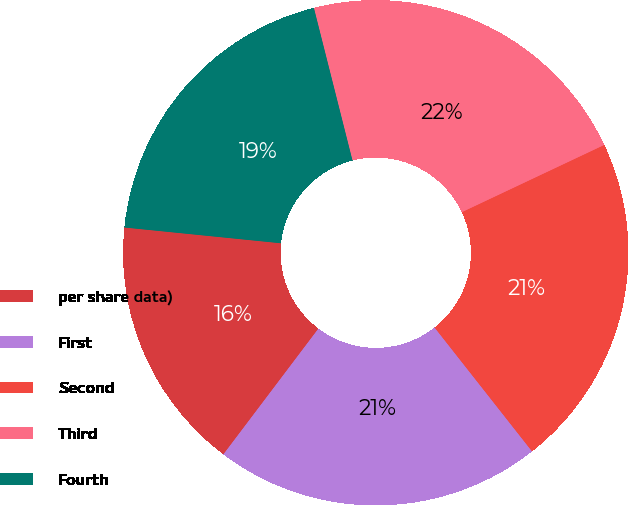Convert chart to OTSL. <chart><loc_0><loc_0><loc_500><loc_500><pie_chart><fcel>per share data)<fcel>First<fcel>Second<fcel>Third<fcel>Fourth<nl><fcel>16.3%<fcel>20.91%<fcel>21.41%<fcel>21.92%<fcel>19.46%<nl></chart> 